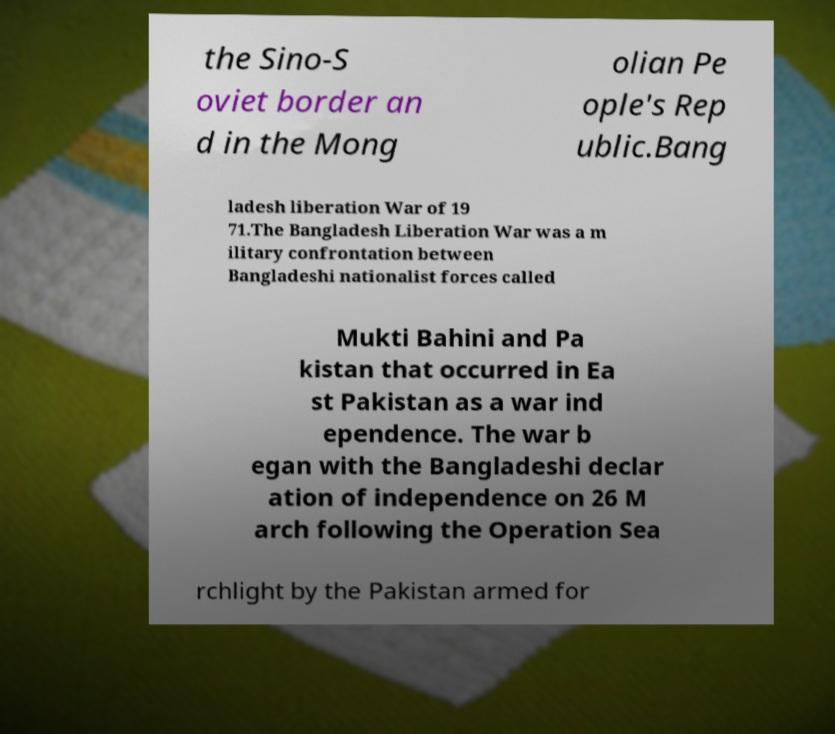Could you assist in decoding the text presented in this image and type it out clearly? the Sino-S oviet border an d in the Mong olian Pe ople's Rep ublic.Bang ladesh liberation War of 19 71.The Bangladesh Liberation War was a m ilitary confrontation between Bangladeshi nationalist forces called Mukti Bahini and Pa kistan that occurred in Ea st Pakistan as a war ind ependence. The war b egan with the Bangladeshi declar ation of independence on 26 M arch following the Operation Sea rchlight by the Pakistan armed for 